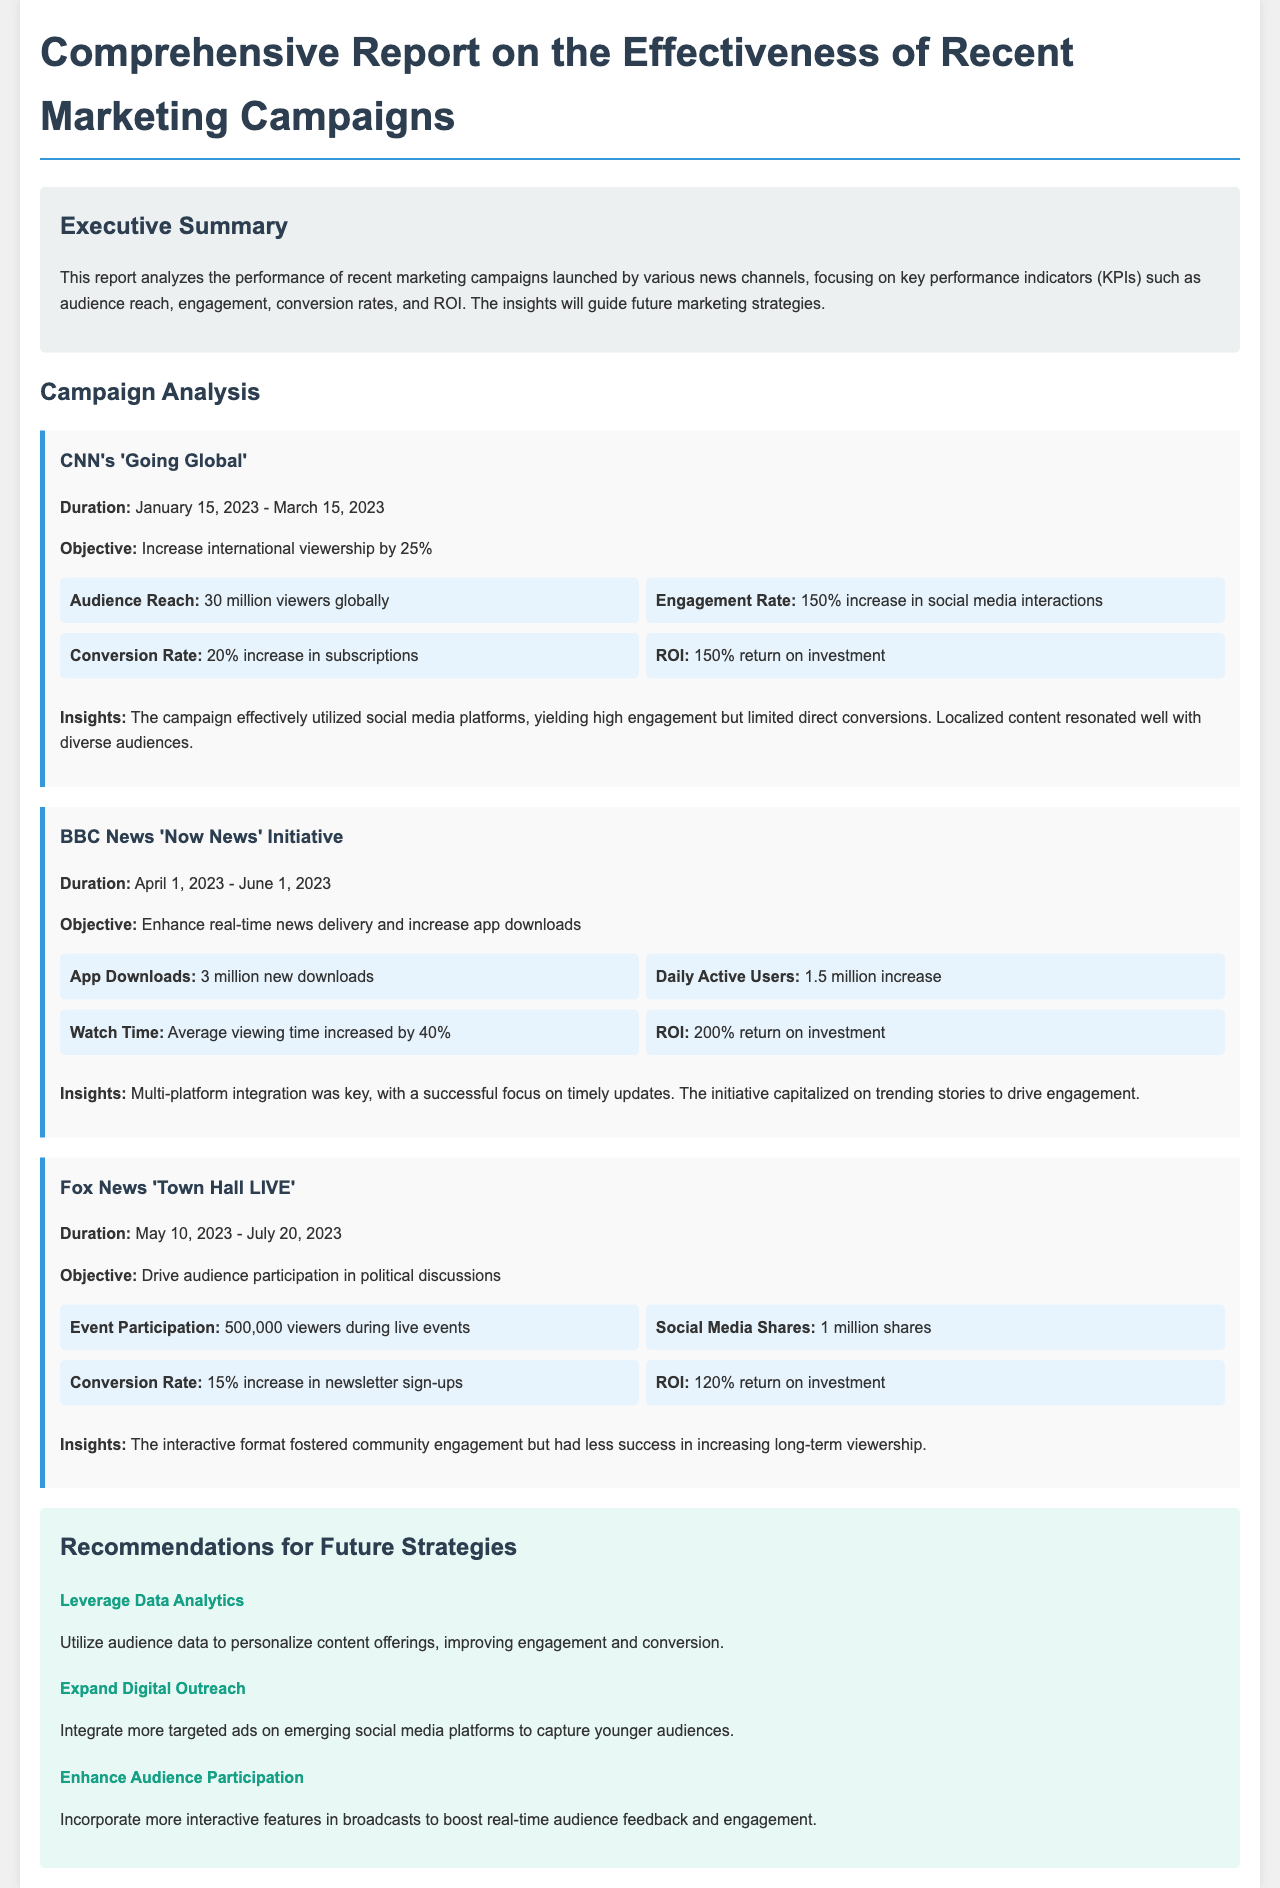What was the objective of CNN's 'Going Global' campaign? The objective was to increase international viewership by 25%.
Answer: Increase international viewership by 25% What was the engagement rate increase for CNN's 'Going Global' campaign? The document states that there was a 150% increase in social media interactions.
Answer: 150% increase How many new app downloads were achieved in the BBC News 'Now News' Initiative? The number of new downloads recorded was 3 million.
Answer: 3 million new downloads What was the average viewing time increase during the BBC News campaign? The report indicated a 40% increase in average viewing time.
Answer: 40% How many viewers participated in Fox News 'Town Hall LIVE' events? The participation recorded was 500,000 viewers during live events.
Answer: 500,000 viewers What recommendation is made regarding audience data? The recommendation is to utilize audience data to personalize content offerings.
Answer: Utilize audience data to personalize content offerings Which campaign had the highest ROI? BBC News 'Now News' Initiative had the highest ROI at 200%.
Answer: 200% What was a major insight from the CNN campaign? The insight was that localized content resonated well with diverse audiences.
Answer: Localized content resonated well with diverse audiences How many strategies are recommended for future marketing efforts? There are three strategies recommended for future marketing efforts.
Answer: Three strategies 